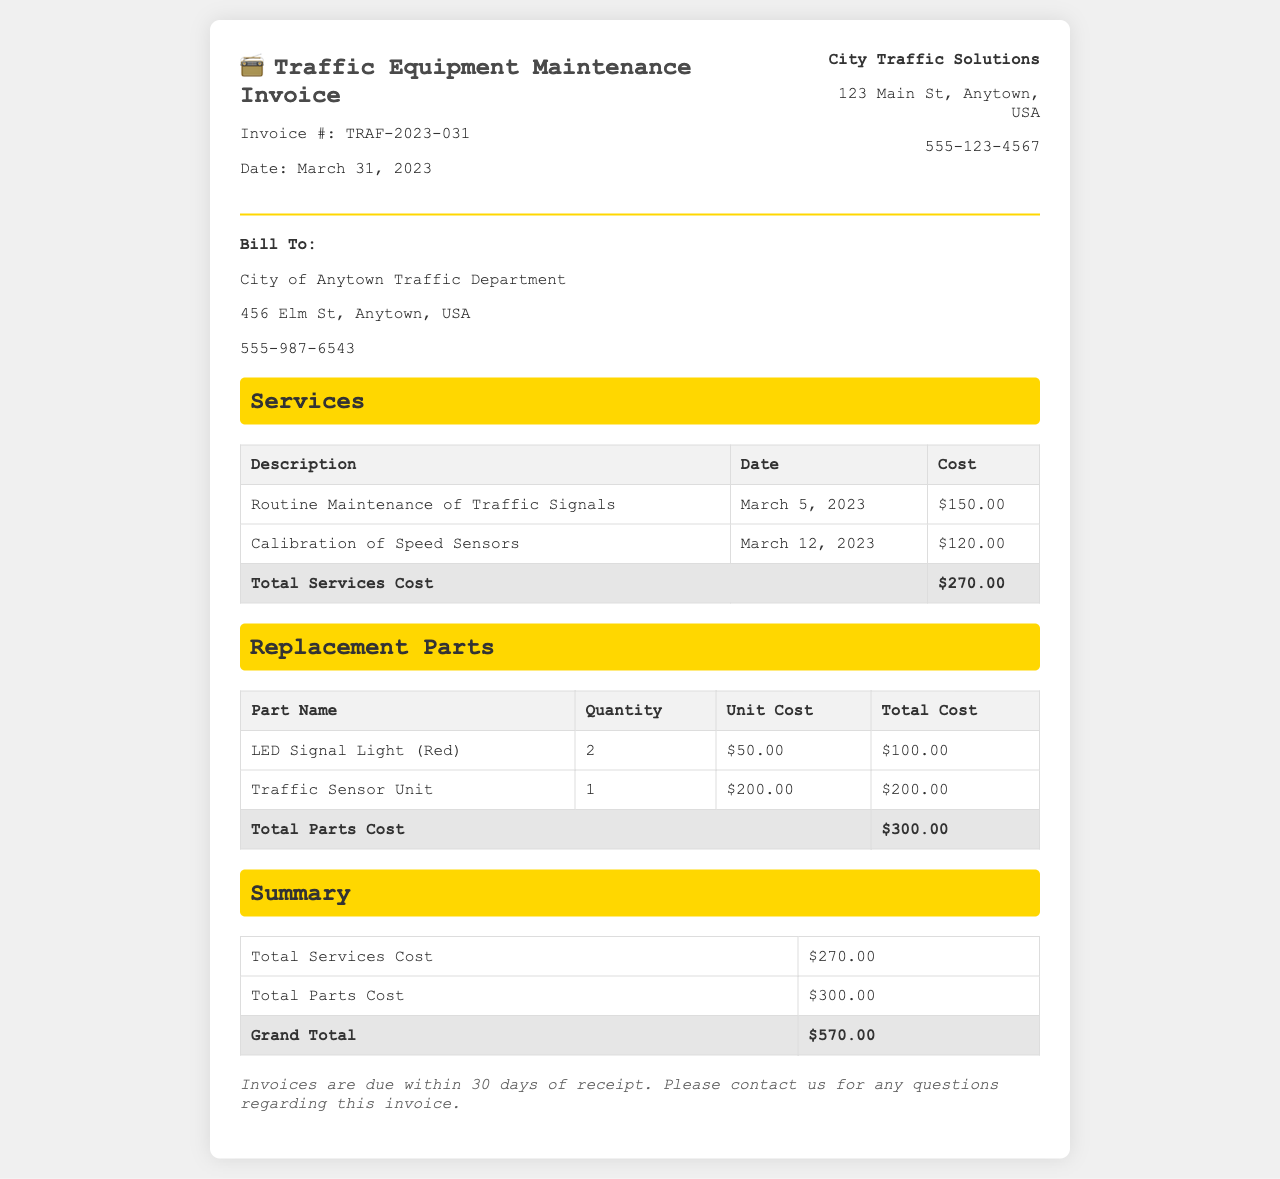What is the invoice number? The invoice number is specifically listed in the header of the document as TRAF-2023-031.
Answer: TRAF-2023-031 What is the date of the invoice? The date of the invoice is provided in the header and is March 31, 2023.
Answer: March 31, 2023 What is the cost for routine maintenance of traffic signals? This cost is detailed in the services section of the invoice, which shows a cost of $150.00.
Answer: $150.00 How many LED Signal Lights were replaced? The replacement parts section specifies that 2 LED Signal Lights (Red) were purchased.
Answer: 2 What is the total cost for all replacement parts? The total parts cost is listed at the bottom of the replacement parts table, showing a total of $300.00.
Answer: $300.00 What is the grand total amount due? The grand total is calculated from the summary section of the invoice, indicating $570.00.
Answer: $570.00 What does the invoice specify regarding payment due date? The notes section states that invoices are due within 30 days of receipt.
Answer: 30 days What service was performed on March 12, 2023? The services table lists "Calibration of Speed Sensors" as the service performed on this date.
Answer: Calibration of Speed Sensors Who is billed for this invoice? The invoice indicates that it is billed to the City of Anytown Traffic Department.
Answer: City of Anytown Traffic Department 